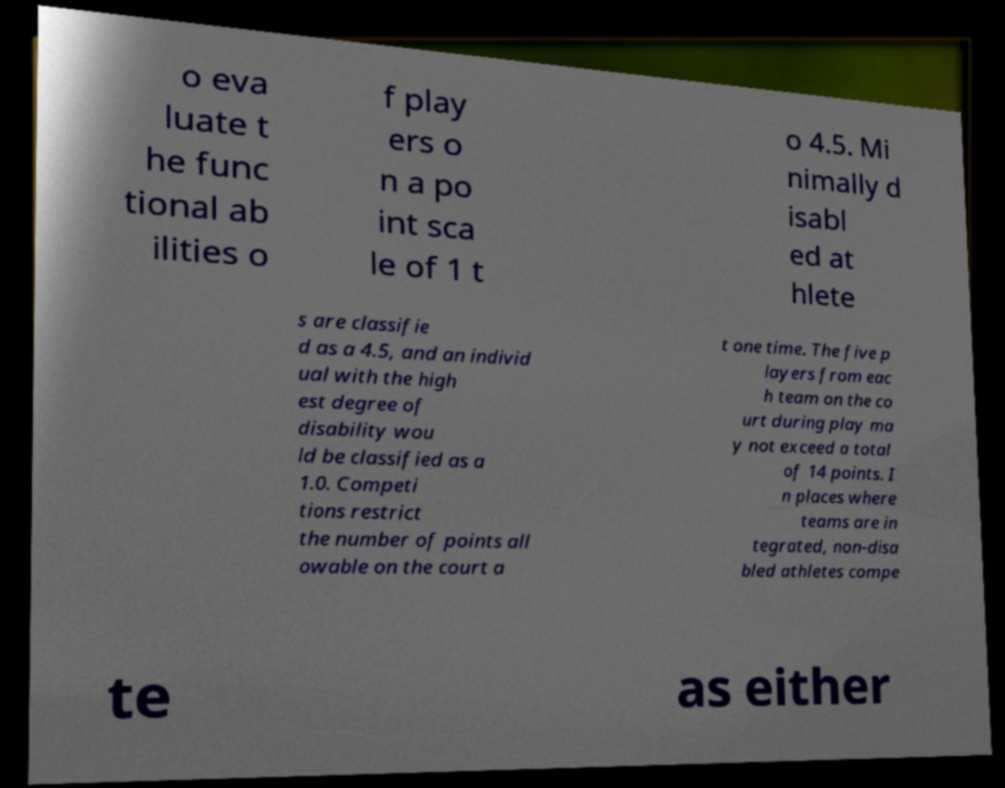Can you read and provide the text displayed in the image?This photo seems to have some interesting text. Can you extract and type it out for me? o eva luate t he func tional ab ilities o f play ers o n a po int sca le of 1 t o 4.5. Mi nimally d isabl ed at hlete s are classifie d as a 4.5, and an individ ual with the high est degree of disability wou ld be classified as a 1.0. Competi tions restrict the number of points all owable on the court a t one time. The five p layers from eac h team on the co urt during play ma y not exceed a total of 14 points. I n places where teams are in tegrated, non-disa bled athletes compe te as either 